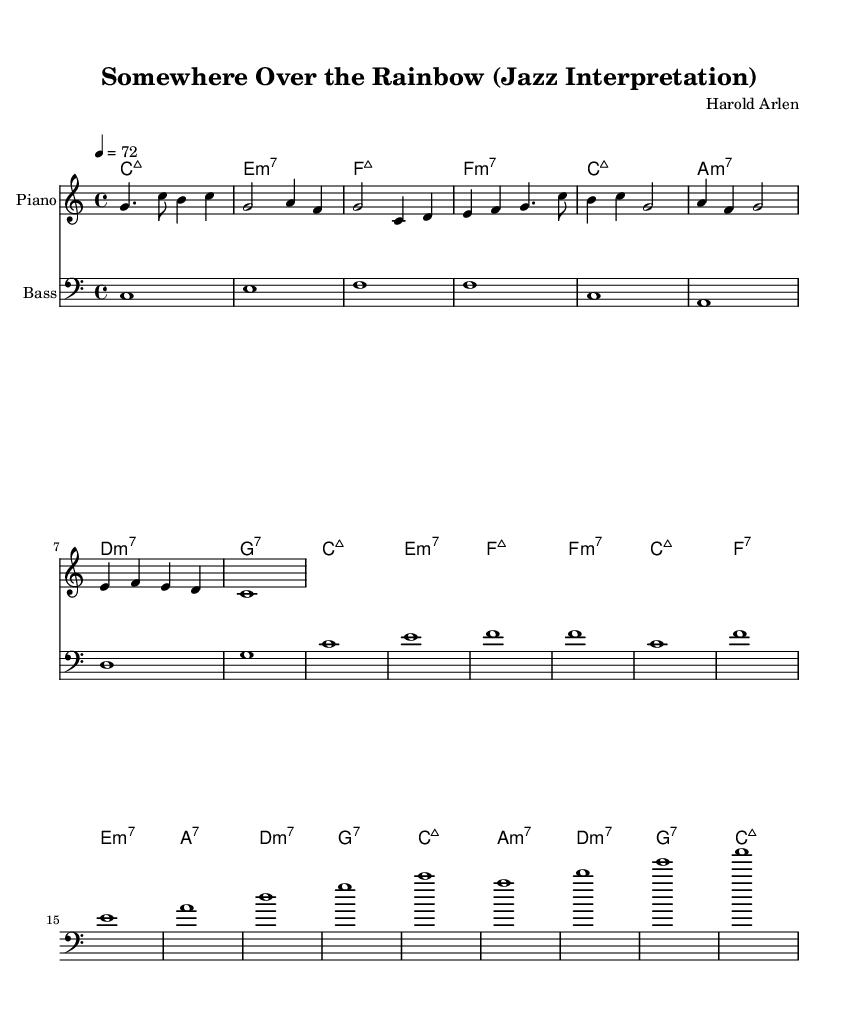What is the key signature of this music? The key signature is indicated by the 'key' command which in this case specifies C major, which has no sharps or flats.
Answer: C major What is the time signature of this piece? The time signature is indicated at the beginning of the score with a 'time' command; it shows 4/4, which means four beats per measure and a quarter note gets one beat.
Answer: 4/4 What is the tempo marking for this arrangement? The tempo marking is specified with a 'tempo' command at the beginning, indicating a quarter note (4) equals 72, which sets the pace for the piece.
Answer: 72 Which chords are used in the first line of the chord progression? The chord progression in the first line starts with C major 7, E minor 7, F major 7, and F minor 7, as indicated in the chordNames block.
Answer: C major 7, E minor 7, F major 7, F minor 7 What is the last note of the melody? The last note of the melody is indicated in the melody section, represented by the final note 'c1', which is a full note in this context.
Answer: c What is the instrument specified for the piano part? The instrument for the piano part is indicated in the 'Staff' block with the 'instrumentName' attribute as "Piano", which shows that this part is written for piano.
Answer: Piano 